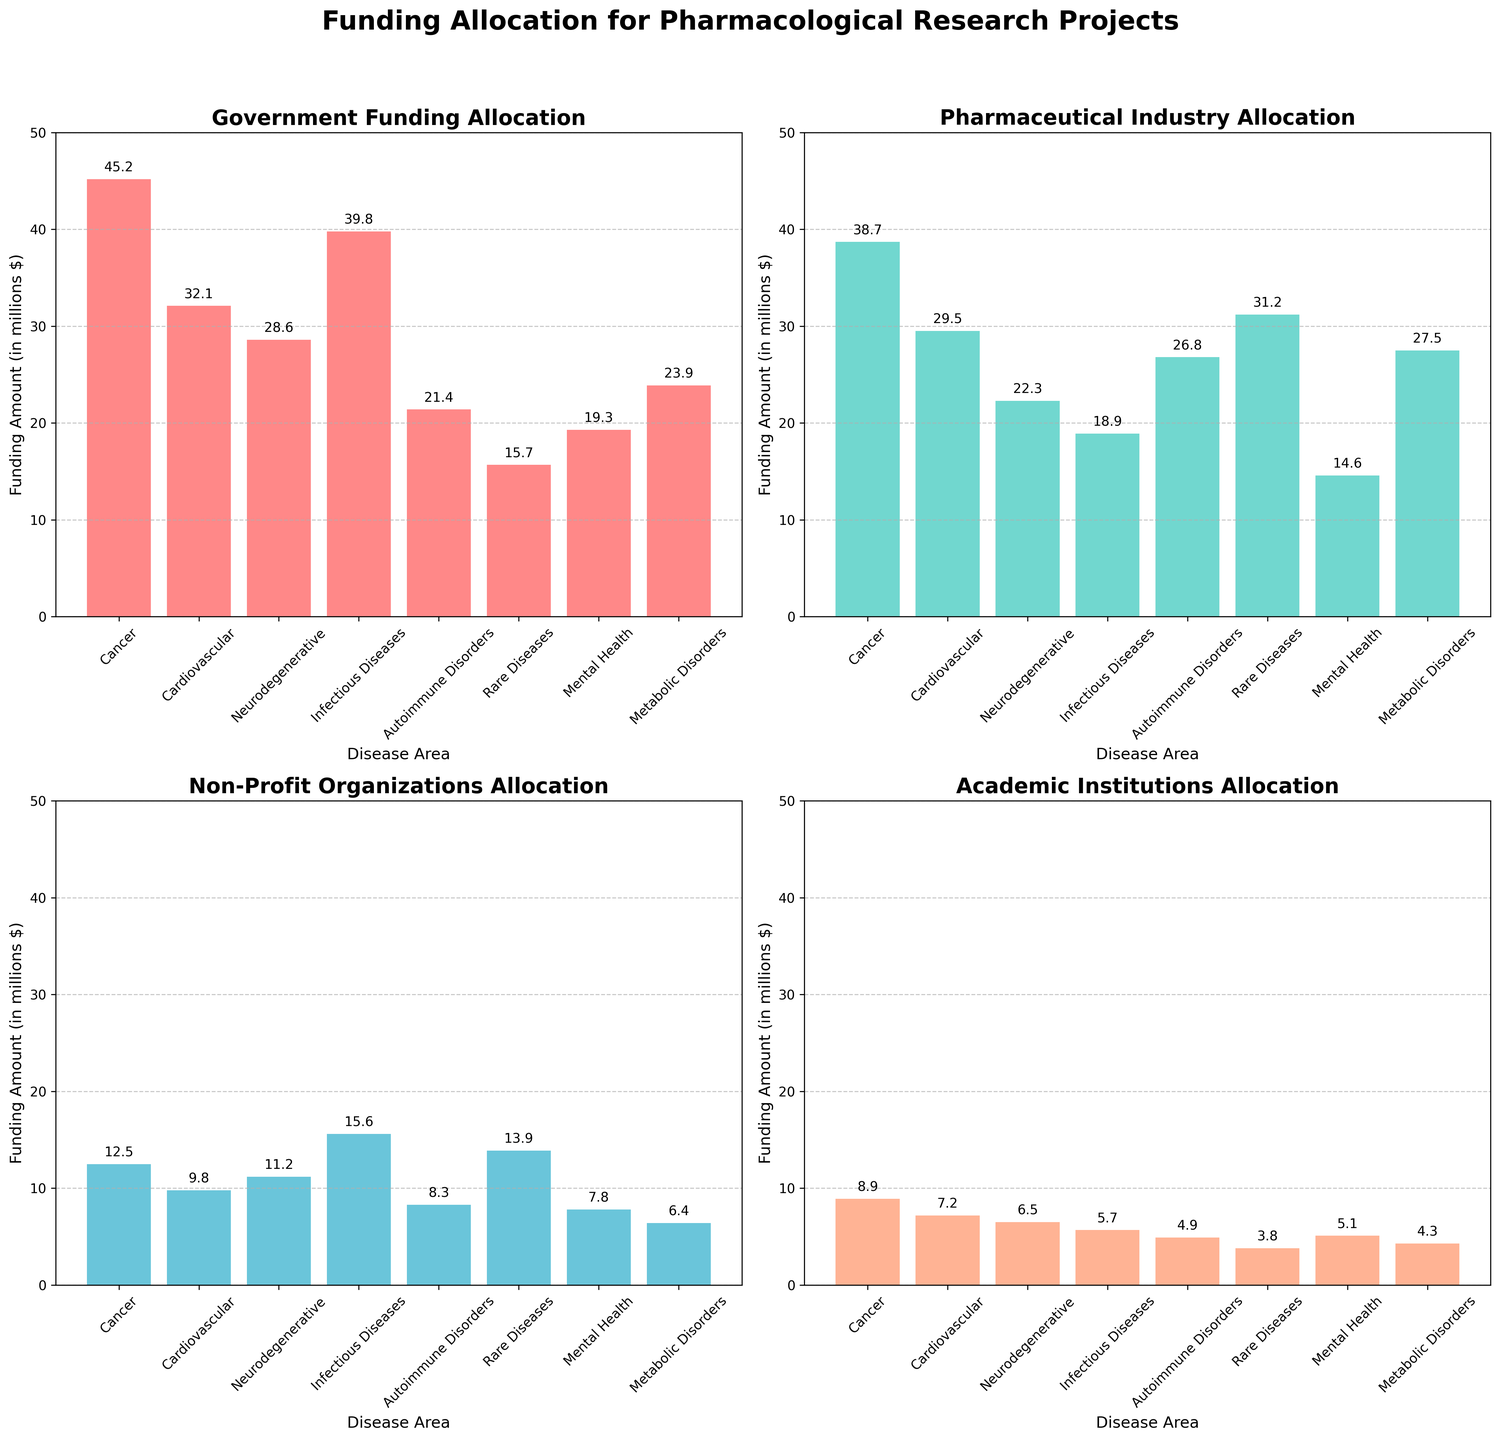What is the total funding amount allocated to Cancer research from the Government? According to the first subplot titled "Government Funding Allocation," the bar corresponding to Cancer research shows a value of 45.2 million dollars.
Answer: 45.2 Which disease area receives the highest funding from Pharmaceutical Industry? The subplot titled "Pharmaceutical Industry Allocation" shows the disease areas and their corresponding funding. The Rare Diseases category has the highest bar with 31.2 million dollars.
Answer: Rare Diseases What is the difference in Government Funding between Cancer and Cardiovascular research? In the "Government Funding Allocation" subplot, Cancer research receives 45.2 million dollars, while Cardiovascular research receives 32.1 million dollars. Subtract the two values to get the difference: 45.2 - 32.1 = 13.1 million dollars.
Answer: 13.1 How much funding does Neurodegenerative research receive from Non-Profit Organizations compared to Academic Institutions? In the "Non-Profit Organizations Allocation" subplot, Neurodegenerative research receives 11.2 million dollars. In the "Academic Institutions Allocation" subplot, it receives 6.5 million dollars. Subtract the two values to get the difference: 11.2 - 6.5 = 4.7 million dollars.
Answer: 4.7 Which funding source allocates the least amount to Metabolic Disorders and how much is it? By examining all four subplots, we see that Academic Institutions allocate the least amount to Metabolic Disorders with 4.3 million dollars, as shown in the "Academic Institutions Allocation" subplot.
Answer: Academic Institutions, 4.3 What is the total funding from Non-Profit Organizations for all research areas combined? To find the total Non-Profit Organizations funding, sum the values from the "Non-Profit Organizations Allocation" subplot: 12.5 + 9.8 + 11.2 + 15.6 + 8.3 + 13.9 + 7.8 + 6.4 = 85.5 million dollars.
Answer: 85.5 Which disease area has more funding from Academic Institutions compared to Pharmaceutical Industry and why? By examining the "Pharmaceutical Industry Allocation" and "Academic Institutions Allocation" subplots, none of the disease areas receive more funding from Academic Institutions (highest is Cancer with 8.9) than from Pharmaceutical Industry (lowest is Mental Health with 14.6).
Answer: None Among Infectious Diseases, what fraction of total funding comes from Non-Profit Organizations in comparison to Government Funding? According to the "Non-Profit Organizations Allocation" subplot, Infectious Diseases receive 15.6 million dollars. From the "Government Funding Allocation" subplot, it receives 39.8 million dollars. Calculate the fraction: 15.6 / 39.8 ≈ 0.39.
Answer: 0.39 What is the average funding amount from the Government across all disease areas? Compute the average Government Funding by summing the values from the "Government Funding Allocation" subplot and dividing by the number of disease areas: (45.2 + 32.1 + 28.6 + 39.8 + 21.4 + 15.7 + 19.3 + 23.9) / 8 ≈ 28.2 million dollars.
Answer: 28.2 Which disease area receives the lowest funding from Non-Profit Organizations and what is the value? The "Non-Profit Organizations Allocation" subplot shows that Mental Health receives the lowest funding, with 7.8 million dollars.
Answer: Mental Health, 7.8 